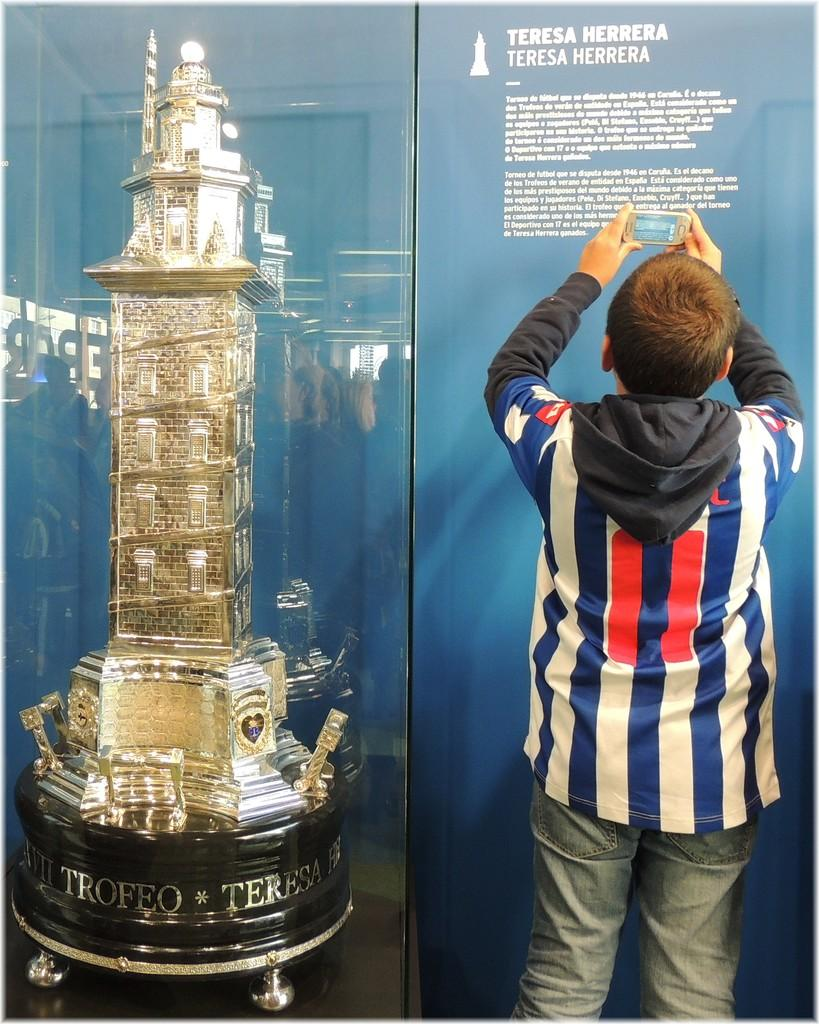<image>
Provide a brief description of the given image. A boy with a cell phone is taking a picture of the text on a display that says Teresa Herrera. 